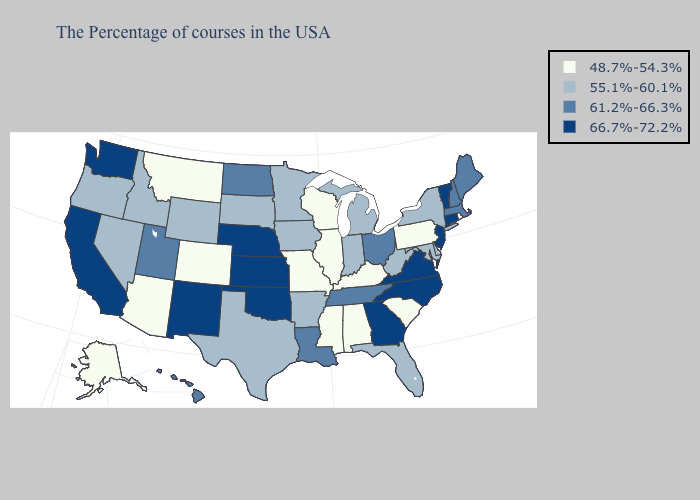Does Pennsylvania have the lowest value in the Northeast?
Give a very brief answer. Yes. What is the value of North Dakota?
Answer briefly. 61.2%-66.3%. What is the highest value in states that border Virginia?
Write a very short answer. 66.7%-72.2%. Among the states that border Montana , does North Dakota have the highest value?
Give a very brief answer. Yes. How many symbols are there in the legend?
Short answer required. 4. Among the states that border Rhode Island , does Massachusetts have the highest value?
Be succinct. No. What is the highest value in states that border Wyoming?
Concise answer only. 66.7%-72.2%. Name the states that have a value in the range 61.2%-66.3%?
Concise answer only. Maine, Massachusetts, New Hampshire, Ohio, Tennessee, Louisiana, North Dakota, Utah, Hawaii. Does Michigan have the lowest value in the USA?
Quick response, please. No. What is the lowest value in the USA?
Quick response, please. 48.7%-54.3%. Does the first symbol in the legend represent the smallest category?
Write a very short answer. Yes. Name the states that have a value in the range 55.1%-60.1%?
Give a very brief answer. New York, Delaware, Maryland, West Virginia, Florida, Michigan, Indiana, Arkansas, Minnesota, Iowa, Texas, South Dakota, Wyoming, Idaho, Nevada, Oregon. Name the states that have a value in the range 66.7%-72.2%?
Quick response, please. Vermont, Connecticut, New Jersey, Virginia, North Carolina, Georgia, Kansas, Nebraska, Oklahoma, New Mexico, California, Washington. Name the states that have a value in the range 66.7%-72.2%?
Be succinct. Vermont, Connecticut, New Jersey, Virginia, North Carolina, Georgia, Kansas, Nebraska, Oklahoma, New Mexico, California, Washington. 